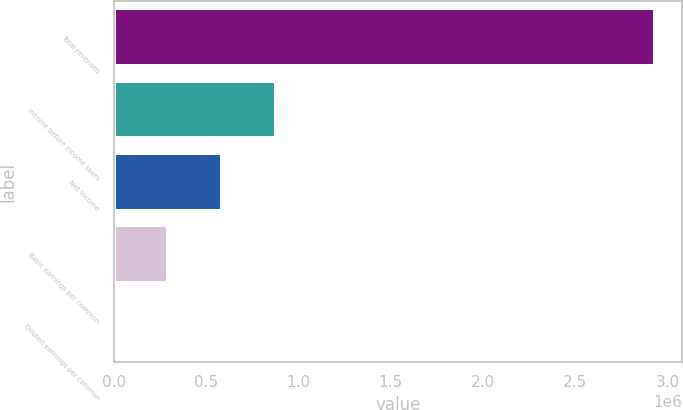<chart> <loc_0><loc_0><loc_500><loc_500><bar_chart><fcel>Total revenues<fcel>Income before income taxes<fcel>Net income<fcel>Basic earnings per common<fcel>Diluted earnings per common<nl><fcel>2.93172e+06<fcel>879515<fcel>586343<fcel>293172<fcel>0.19<nl></chart> 